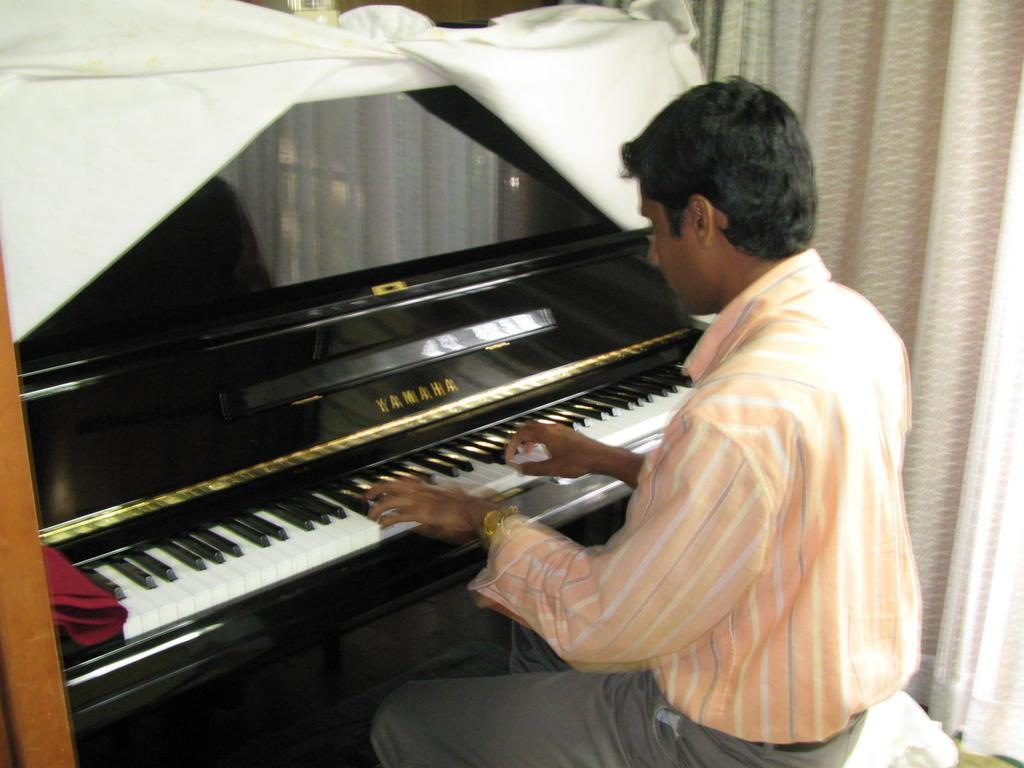What is the person in the image doing? The person is sitting in a chair and playing a piano. What brand of piano is being played? The piano has "Yamaha" written on it. Can you hear the monkey singing along with the piano in the image? There is no monkey or singing in the image; it only shows a person playing a Yamaha piano. 